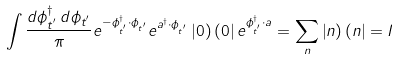<formula> <loc_0><loc_0><loc_500><loc_500>\int \frac { d { \phi } ^ { \dagger } _ { t ^ { ^ { \prime } } } \, d { \phi } _ { t ^ { ^ { \prime } } } } { \pi } e ^ { - { \phi } ^ { \dagger } _ { t ^ { ^ { \prime } } } \cdot { \phi } _ { t ^ { ^ { \prime } } } } e ^ { a ^ { \dagger } \cdot { \phi } _ { t ^ { ^ { \prime } } } } \left | 0 \right ) \left ( 0 \right | e ^ { { \phi } ^ { \dagger } _ { t ^ { ^ { \prime } } } \cdot a } = \sum _ { n } \left | n \right ) \left ( n \right | = I</formula> 